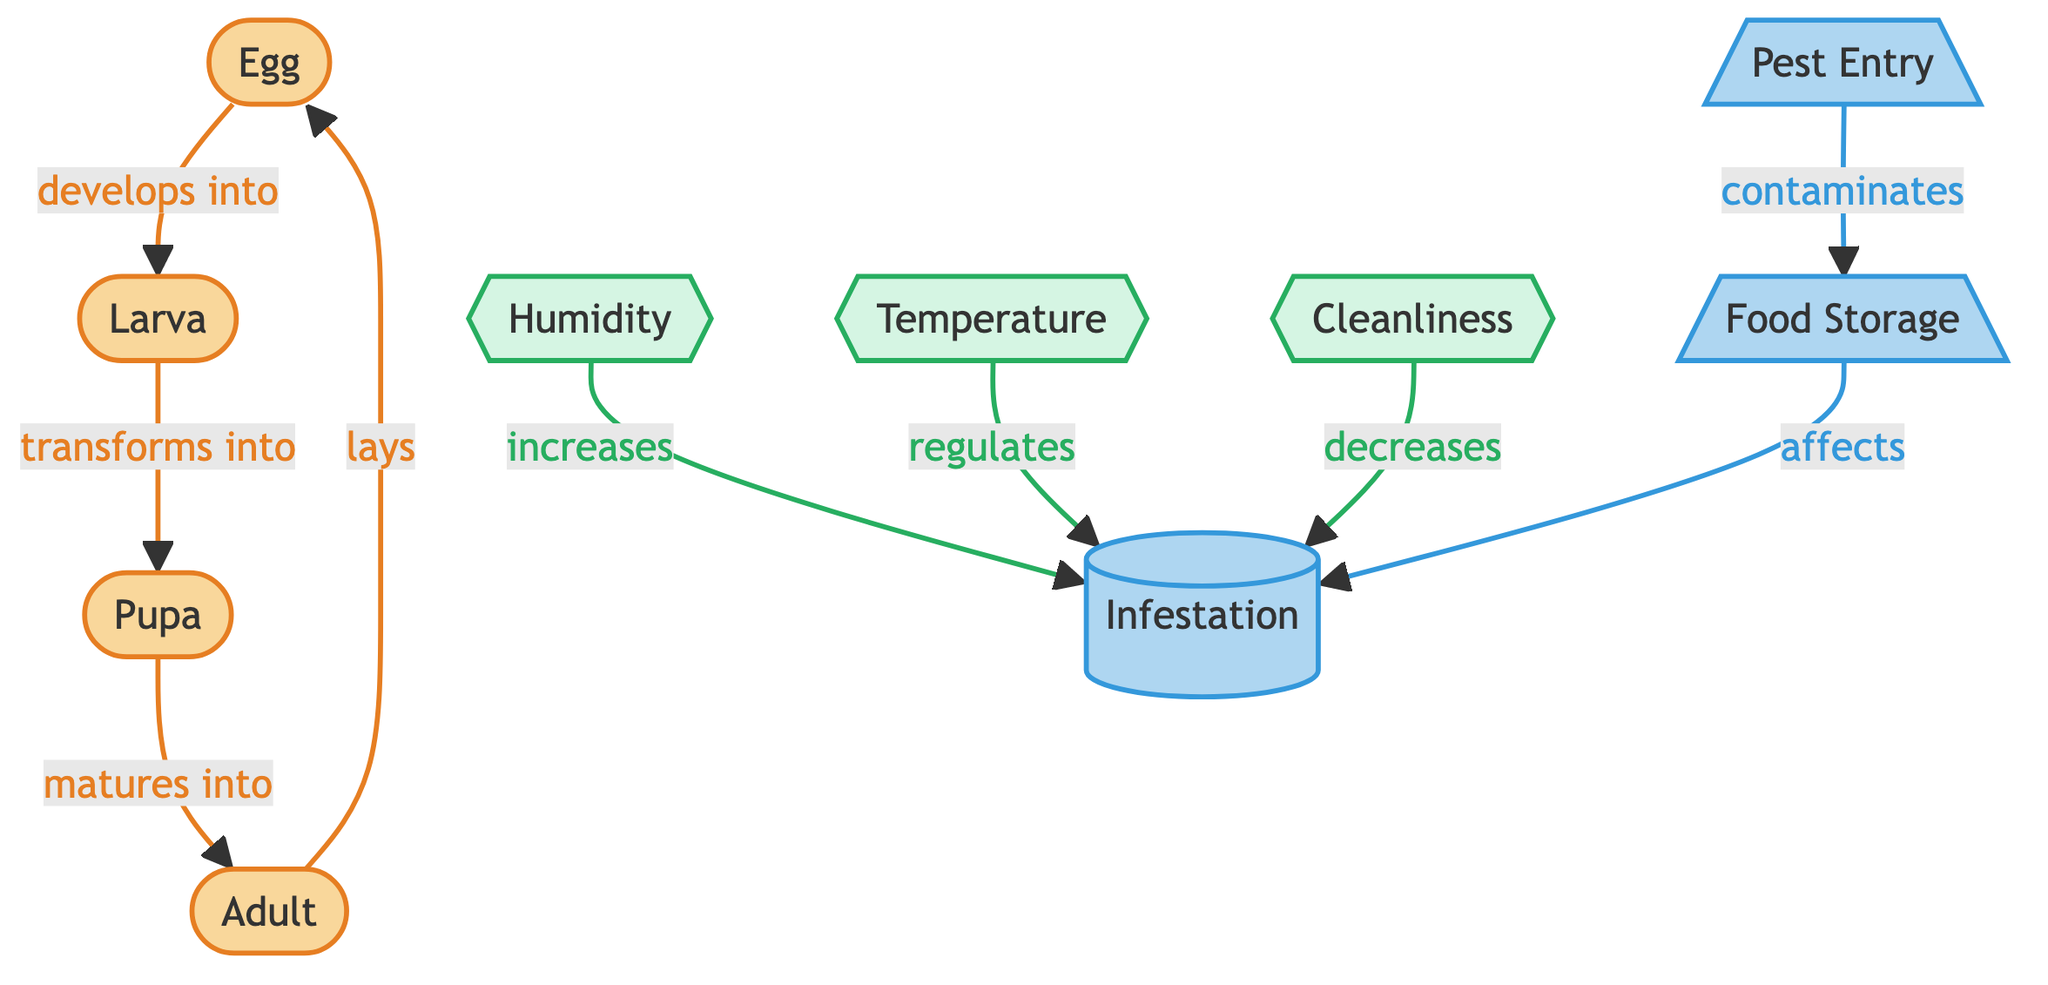What are the four stages of the pest lifecycle? The diagram shows the lifecycle stages clearly: the four stages are Egg, Larva, Pupa, and Adult. Each stage leads to the next, forming a complete lifecycle.
Answer: Egg, Larva, Pupa, Adult Which two factors increase infestation? The diagram indicates that Humidity and Temperature are factors that affect infestation. Specifically, Humidity increases infestation, while Temperature regulates it.
Answer: Humidity, Temperature What role does cleanliness play in the infestation? According to the diagram, Cleanliness decreases infestation, meaning that maintaining cleanliness can help reduce pest problems in food storage.
Answer: Decreases How many nodes are represented in the lifecycle section? The lifecycle section has four stages: Egg, Larva, Pupa, and Adult. Each stage is represented as a distinct node.
Answer: Four Which environmental element contaminates food storage? The diagram highlights Pest Entry as the element that contaminates Food Storage, indicating how pests infiltrate and impact stored food.
Answer: Pest Entry What happens to larvae in the lifecycle? The diagram details that Larva transforms into Pupa, indicating a significant developmental change between these two stages of the lifecycle.
Answer: Transforms into Pupa How does humidity affect infestation? The diagram shows that Humidity increases Infestation, meaning higher humidity levels can lead to greater pest problems, which is crucial for food safety management.
Answer: Increases What is the relationship between food storage and infestation? The diagram indicates that Food Storage affects Infestation, suggesting that conditions related to food storage can lead to increases in pest presence if not managed properly.
Answer: Affects How many environmental factors are mentioned in relation to infestation? The diagram lists three environmental factors: Humidity, Temperature, and Cleanliness, which indicate their combined effect on pest infestation scenarios.
Answer: Three 